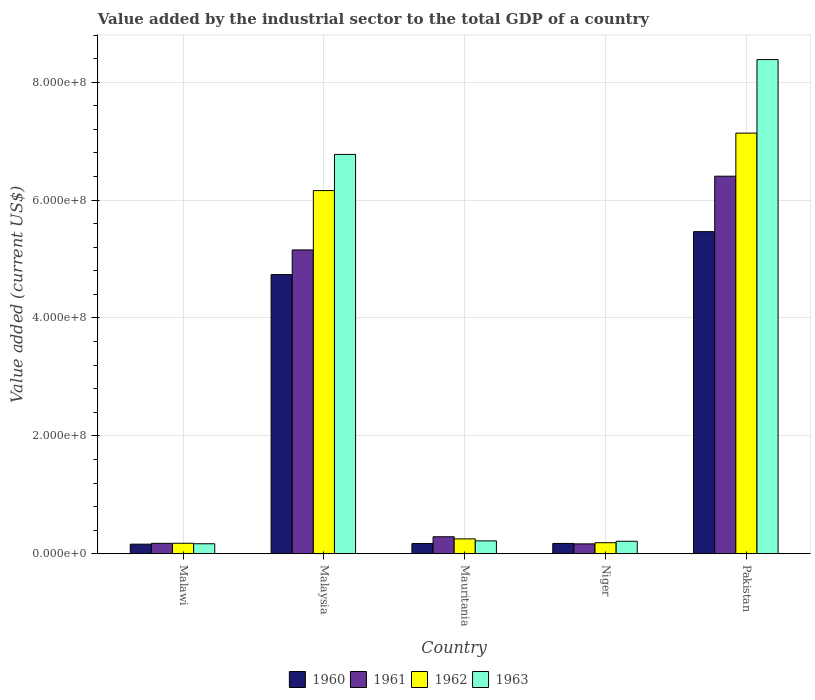How many groups of bars are there?
Your answer should be compact. 5. Are the number of bars per tick equal to the number of legend labels?
Ensure brevity in your answer.  Yes. What is the label of the 4th group of bars from the left?
Offer a terse response. Niger. What is the value added by the industrial sector to the total GDP in 1960 in Malawi?
Offer a very short reply. 1.62e+07. Across all countries, what is the maximum value added by the industrial sector to the total GDP in 1962?
Make the answer very short. 7.14e+08. Across all countries, what is the minimum value added by the industrial sector to the total GDP in 1961?
Your response must be concise. 1.67e+07. In which country was the value added by the industrial sector to the total GDP in 1963 minimum?
Give a very brief answer. Malawi. What is the total value added by the industrial sector to the total GDP in 1961 in the graph?
Offer a terse response. 1.22e+09. What is the difference between the value added by the industrial sector to the total GDP in 1963 in Malawi and that in Niger?
Offer a very short reply. -4.25e+06. What is the difference between the value added by the industrial sector to the total GDP in 1963 in Malaysia and the value added by the industrial sector to the total GDP in 1962 in Mauritania?
Your answer should be compact. 6.52e+08. What is the average value added by the industrial sector to the total GDP in 1963 per country?
Keep it short and to the point. 3.15e+08. What is the difference between the value added by the industrial sector to the total GDP of/in 1963 and value added by the industrial sector to the total GDP of/in 1960 in Malaysia?
Your answer should be very brief. 2.04e+08. In how many countries, is the value added by the industrial sector to the total GDP in 1963 greater than 640000000 US$?
Provide a succinct answer. 2. What is the ratio of the value added by the industrial sector to the total GDP in 1961 in Malaysia to that in Niger?
Give a very brief answer. 30.78. Is the value added by the industrial sector to the total GDP in 1962 in Malaysia less than that in Mauritania?
Provide a short and direct response. No. What is the difference between the highest and the second highest value added by the industrial sector to the total GDP in 1962?
Provide a short and direct response. 9.75e+07. What is the difference between the highest and the lowest value added by the industrial sector to the total GDP in 1961?
Make the answer very short. 6.24e+08. In how many countries, is the value added by the industrial sector to the total GDP in 1962 greater than the average value added by the industrial sector to the total GDP in 1962 taken over all countries?
Provide a succinct answer. 2. What does the 3rd bar from the right in Niger represents?
Your response must be concise. 1961. Is it the case that in every country, the sum of the value added by the industrial sector to the total GDP in 1963 and value added by the industrial sector to the total GDP in 1960 is greater than the value added by the industrial sector to the total GDP in 1962?
Your response must be concise. Yes. How many bars are there?
Give a very brief answer. 20. Are all the bars in the graph horizontal?
Provide a succinct answer. No. Are the values on the major ticks of Y-axis written in scientific E-notation?
Provide a short and direct response. Yes. Does the graph contain any zero values?
Ensure brevity in your answer.  No. Where does the legend appear in the graph?
Offer a very short reply. Bottom center. How many legend labels are there?
Your answer should be very brief. 4. How are the legend labels stacked?
Ensure brevity in your answer.  Horizontal. What is the title of the graph?
Keep it short and to the point. Value added by the industrial sector to the total GDP of a country. Does "1981" appear as one of the legend labels in the graph?
Your answer should be very brief. No. What is the label or title of the X-axis?
Your answer should be very brief. Country. What is the label or title of the Y-axis?
Your answer should be compact. Value added (current US$). What is the Value added (current US$) of 1960 in Malawi?
Offer a very short reply. 1.62e+07. What is the Value added (current US$) of 1961 in Malawi?
Give a very brief answer. 1.76e+07. What is the Value added (current US$) in 1962 in Malawi?
Give a very brief answer. 1.78e+07. What is the Value added (current US$) in 1963 in Malawi?
Give a very brief answer. 1.69e+07. What is the Value added (current US$) in 1960 in Malaysia?
Give a very brief answer. 4.74e+08. What is the Value added (current US$) in 1961 in Malaysia?
Make the answer very short. 5.15e+08. What is the Value added (current US$) in 1962 in Malaysia?
Offer a very short reply. 6.16e+08. What is the Value added (current US$) in 1963 in Malaysia?
Your answer should be compact. 6.77e+08. What is the Value added (current US$) in 1960 in Mauritania?
Your answer should be compact. 1.73e+07. What is the Value added (current US$) of 1961 in Mauritania?
Ensure brevity in your answer.  2.88e+07. What is the Value added (current US$) in 1962 in Mauritania?
Ensure brevity in your answer.  2.52e+07. What is the Value added (current US$) in 1963 in Mauritania?
Offer a terse response. 2.18e+07. What is the Value added (current US$) of 1960 in Niger?
Your answer should be very brief. 1.75e+07. What is the Value added (current US$) in 1961 in Niger?
Provide a short and direct response. 1.67e+07. What is the Value added (current US$) in 1962 in Niger?
Offer a terse response. 1.87e+07. What is the Value added (current US$) in 1963 in Niger?
Make the answer very short. 2.12e+07. What is the Value added (current US$) of 1960 in Pakistan?
Your answer should be compact. 5.46e+08. What is the Value added (current US$) in 1961 in Pakistan?
Provide a short and direct response. 6.40e+08. What is the Value added (current US$) of 1962 in Pakistan?
Your response must be concise. 7.14e+08. What is the Value added (current US$) of 1963 in Pakistan?
Keep it short and to the point. 8.38e+08. Across all countries, what is the maximum Value added (current US$) in 1960?
Keep it short and to the point. 5.46e+08. Across all countries, what is the maximum Value added (current US$) of 1961?
Your answer should be very brief. 6.40e+08. Across all countries, what is the maximum Value added (current US$) in 1962?
Your response must be concise. 7.14e+08. Across all countries, what is the maximum Value added (current US$) of 1963?
Your answer should be compact. 8.38e+08. Across all countries, what is the minimum Value added (current US$) in 1960?
Make the answer very short. 1.62e+07. Across all countries, what is the minimum Value added (current US$) of 1961?
Provide a short and direct response. 1.67e+07. Across all countries, what is the minimum Value added (current US$) of 1962?
Your answer should be very brief. 1.78e+07. Across all countries, what is the minimum Value added (current US$) of 1963?
Ensure brevity in your answer.  1.69e+07. What is the total Value added (current US$) of 1960 in the graph?
Your answer should be very brief. 1.07e+09. What is the total Value added (current US$) of 1961 in the graph?
Your answer should be very brief. 1.22e+09. What is the total Value added (current US$) of 1962 in the graph?
Make the answer very short. 1.39e+09. What is the total Value added (current US$) of 1963 in the graph?
Ensure brevity in your answer.  1.58e+09. What is the difference between the Value added (current US$) in 1960 in Malawi and that in Malaysia?
Make the answer very short. -4.57e+08. What is the difference between the Value added (current US$) in 1961 in Malawi and that in Malaysia?
Provide a succinct answer. -4.98e+08. What is the difference between the Value added (current US$) of 1962 in Malawi and that in Malaysia?
Give a very brief answer. -5.98e+08. What is the difference between the Value added (current US$) of 1963 in Malawi and that in Malaysia?
Your response must be concise. -6.61e+08. What is the difference between the Value added (current US$) in 1960 in Malawi and that in Mauritania?
Ensure brevity in your answer.  -1.06e+06. What is the difference between the Value added (current US$) in 1961 in Malawi and that in Mauritania?
Make the answer very short. -1.12e+07. What is the difference between the Value added (current US$) of 1962 in Malawi and that in Mauritania?
Provide a short and direct response. -7.44e+06. What is the difference between the Value added (current US$) in 1963 in Malawi and that in Mauritania?
Make the answer very short. -4.90e+06. What is the difference between the Value added (current US$) of 1960 in Malawi and that in Niger?
Ensure brevity in your answer.  -1.23e+06. What is the difference between the Value added (current US$) of 1961 in Malawi and that in Niger?
Keep it short and to the point. 8.98e+05. What is the difference between the Value added (current US$) of 1962 in Malawi and that in Niger?
Provide a short and direct response. -9.35e+05. What is the difference between the Value added (current US$) of 1963 in Malawi and that in Niger?
Keep it short and to the point. -4.25e+06. What is the difference between the Value added (current US$) of 1960 in Malawi and that in Pakistan?
Offer a terse response. -5.30e+08. What is the difference between the Value added (current US$) of 1961 in Malawi and that in Pakistan?
Ensure brevity in your answer.  -6.23e+08. What is the difference between the Value added (current US$) of 1962 in Malawi and that in Pakistan?
Provide a succinct answer. -6.96e+08. What is the difference between the Value added (current US$) of 1963 in Malawi and that in Pakistan?
Your answer should be compact. -8.21e+08. What is the difference between the Value added (current US$) of 1960 in Malaysia and that in Mauritania?
Provide a short and direct response. 4.56e+08. What is the difference between the Value added (current US$) in 1961 in Malaysia and that in Mauritania?
Provide a succinct answer. 4.87e+08. What is the difference between the Value added (current US$) of 1962 in Malaysia and that in Mauritania?
Offer a terse response. 5.91e+08. What is the difference between the Value added (current US$) of 1963 in Malaysia and that in Mauritania?
Offer a very short reply. 6.56e+08. What is the difference between the Value added (current US$) of 1960 in Malaysia and that in Niger?
Make the answer very short. 4.56e+08. What is the difference between the Value added (current US$) of 1961 in Malaysia and that in Niger?
Make the answer very short. 4.99e+08. What is the difference between the Value added (current US$) in 1962 in Malaysia and that in Niger?
Ensure brevity in your answer.  5.97e+08. What is the difference between the Value added (current US$) in 1963 in Malaysia and that in Niger?
Provide a short and direct response. 6.56e+08. What is the difference between the Value added (current US$) of 1960 in Malaysia and that in Pakistan?
Your answer should be compact. -7.29e+07. What is the difference between the Value added (current US$) in 1961 in Malaysia and that in Pakistan?
Provide a short and direct response. -1.25e+08. What is the difference between the Value added (current US$) in 1962 in Malaysia and that in Pakistan?
Give a very brief answer. -9.75e+07. What is the difference between the Value added (current US$) in 1963 in Malaysia and that in Pakistan?
Your response must be concise. -1.61e+08. What is the difference between the Value added (current US$) of 1960 in Mauritania and that in Niger?
Give a very brief answer. -1.73e+05. What is the difference between the Value added (current US$) in 1961 in Mauritania and that in Niger?
Offer a terse response. 1.21e+07. What is the difference between the Value added (current US$) of 1962 in Mauritania and that in Niger?
Offer a very short reply. 6.51e+06. What is the difference between the Value added (current US$) in 1963 in Mauritania and that in Niger?
Keep it short and to the point. 6.57e+05. What is the difference between the Value added (current US$) of 1960 in Mauritania and that in Pakistan?
Your response must be concise. -5.29e+08. What is the difference between the Value added (current US$) of 1961 in Mauritania and that in Pakistan?
Your answer should be very brief. -6.12e+08. What is the difference between the Value added (current US$) of 1962 in Mauritania and that in Pakistan?
Provide a short and direct response. -6.88e+08. What is the difference between the Value added (current US$) of 1963 in Mauritania and that in Pakistan?
Provide a short and direct response. -8.16e+08. What is the difference between the Value added (current US$) of 1960 in Niger and that in Pakistan?
Your response must be concise. -5.29e+08. What is the difference between the Value added (current US$) of 1961 in Niger and that in Pakistan?
Offer a terse response. -6.24e+08. What is the difference between the Value added (current US$) of 1962 in Niger and that in Pakistan?
Make the answer very short. -6.95e+08. What is the difference between the Value added (current US$) in 1963 in Niger and that in Pakistan?
Your answer should be compact. -8.17e+08. What is the difference between the Value added (current US$) of 1960 in Malawi and the Value added (current US$) of 1961 in Malaysia?
Make the answer very short. -4.99e+08. What is the difference between the Value added (current US$) of 1960 in Malawi and the Value added (current US$) of 1962 in Malaysia?
Make the answer very short. -6.00e+08. What is the difference between the Value added (current US$) in 1960 in Malawi and the Value added (current US$) in 1963 in Malaysia?
Offer a terse response. -6.61e+08. What is the difference between the Value added (current US$) in 1961 in Malawi and the Value added (current US$) in 1962 in Malaysia?
Make the answer very short. -5.98e+08. What is the difference between the Value added (current US$) of 1961 in Malawi and the Value added (current US$) of 1963 in Malaysia?
Provide a short and direct response. -6.60e+08. What is the difference between the Value added (current US$) in 1962 in Malawi and the Value added (current US$) in 1963 in Malaysia?
Provide a succinct answer. -6.60e+08. What is the difference between the Value added (current US$) in 1960 in Malawi and the Value added (current US$) in 1961 in Mauritania?
Provide a succinct answer. -1.26e+07. What is the difference between the Value added (current US$) in 1960 in Malawi and the Value added (current US$) in 1962 in Mauritania?
Offer a terse response. -8.98e+06. What is the difference between the Value added (current US$) in 1960 in Malawi and the Value added (current US$) in 1963 in Mauritania?
Provide a succinct answer. -5.60e+06. What is the difference between the Value added (current US$) of 1961 in Malawi and the Value added (current US$) of 1962 in Mauritania?
Your answer should be compact. -7.58e+06. What is the difference between the Value added (current US$) in 1961 in Malawi and the Value added (current US$) in 1963 in Mauritania?
Ensure brevity in your answer.  -4.20e+06. What is the difference between the Value added (current US$) in 1962 in Malawi and the Value added (current US$) in 1963 in Mauritania?
Provide a short and direct response. -4.06e+06. What is the difference between the Value added (current US$) in 1960 in Malawi and the Value added (current US$) in 1961 in Niger?
Provide a succinct answer. -5.02e+05. What is the difference between the Value added (current US$) in 1960 in Malawi and the Value added (current US$) in 1962 in Niger?
Your response must be concise. -2.48e+06. What is the difference between the Value added (current US$) of 1960 in Malawi and the Value added (current US$) of 1963 in Niger?
Make the answer very short. -4.95e+06. What is the difference between the Value added (current US$) of 1961 in Malawi and the Value added (current US$) of 1962 in Niger?
Make the answer very short. -1.08e+06. What is the difference between the Value added (current US$) of 1961 in Malawi and the Value added (current US$) of 1963 in Niger?
Give a very brief answer. -3.55e+06. What is the difference between the Value added (current US$) in 1962 in Malawi and the Value added (current US$) in 1963 in Niger?
Ensure brevity in your answer.  -3.41e+06. What is the difference between the Value added (current US$) in 1960 in Malawi and the Value added (current US$) in 1961 in Pakistan?
Provide a succinct answer. -6.24e+08. What is the difference between the Value added (current US$) of 1960 in Malawi and the Value added (current US$) of 1962 in Pakistan?
Give a very brief answer. -6.97e+08. What is the difference between the Value added (current US$) in 1960 in Malawi and the Value added (current US$) in 1963 in Pakistan?
Provide a short and direct response. -8.22e+08. What is the difference between the Value added (current US$) of 1961 in Malawi and the Value added (current US$) of 1962 in Pakistan?
Offer a very short reply. -6.96e+08. What is the difference between the Value added (current US$) in 1961 in Malawi and the Value added (current US$) in 1963 in Pakistan?
Your answer should be compact. -8.21e+08. What is the difference between the Value added (current US$) in 1962 in Malawi and the Value added (current US$) in 1963 in Pakistan?
Offer a terse response. -8.21e+08. What is the difference between the Value added (current US$) in 1960 in Malaysia and the Value added (current US$) in 1961 in Mauritania?
Offer a very short reply. 4.45e+08. What is the difference between the Value added (current US$) in 1960 in Malaysia and the Value added (current US$) in 1962 in Mauritania?
Ensure brevity in your answer.  4.48e+08. What is the difference between the Value added (current US$) in 1960 in Malaysia and the Value added (current US$) in 1963 in Mauritania?
Make the answer very short. 4.52e+08. What is the difference between the Value added (current US$) in 1961 in Malaysia and the Value added (current US$) in 1962 in Mauritania?
Offer a terse response. 4.90e+08. What is the difference between the Value added (current US$) of 1961 in Malaysia and the Value added (current US$) of 1963 in Mauritania?
Keep it short and to the point. 4.94e+08. What is the difference between the Value added (current US$) in 1962 in Malaysia and the Value added (current US$) in 1963 in Mauritania?
Make the answer very short. 5.94e+08. What is the difference between the Value added (current US$) of 1960 in Malaysia and the Value added (current US$) of 1961 in Niger?
Offer a very short reply. 4.57e+08. What is the difference between the Value added (current US$) in 1960 in Malaysia and the Value added (current US$) in 1962 in Niger?
Give a very brief answer. 4.55e+08. What is the difference between the Value added (current US$) in 1960 in Malaysia and the Value added (current US$) in 1963 in Niger?
Your answer should be very brief. 4.52e+08. What is the difference between the Value added (current US$) of 1961 in Malaysia and the Value added (current US$) of 1962 in Niger?
Give a very brief answer. 4.97e+08. What is the difference between the Value added (current US$) in 1961 in Malaysia and the Value added (current US$) in 1963 in Niger?
Ensure brevity in your answer.  4.94e+08. What is the difference between the Value added (current US$) of 1962 in Malaysia and the Value added (current US$) of 1963 in Niger?
Your answer should be very brief. 5.95e+08. What is the difference between the Value added (current US$) of 1960 in Malaysia and the Value added (current US$) of 1961 in Pakistan?
Make the answer very short. -1.67e+08. What is the difference between the Value added (current US$) in 1960 in Malaysia and the Value added (current US$) in 1962 in Pakistan?
Keep it short and to the point. -2.40e+08. What is the difference between the Value added (current US$) of 1960 in Malaysia and the Value added (current US$) of 1963 in Pakistan?
Your answer should be very brief. -3.65e+08. What is the difference between the Value added (current US$) in 1961 in Malaysia and the Value added (current US$) in 1962 in Pakistan?
Your answer should be very brief. -1.98e+08. What is the difference between the Value added (current US$) in 1961 in Malaysia and the Value added (current US$) in 1963 in Pakistan?
Your answer should be very brief. -3.23e+08. What is the difference between the Value added (current US$) in 1962 in Malaysia and the Value added (current US$) in 1963 in Pakistan?
Your response must be concise. -2.22e+08. What is the difference between the Value added (current US$) of 1960 in Mauritania and the Value added (current US$) of 1961 in Niger?
Your answer should be compact. 5.53e+05. What is the difference between the Value added (current US$) in 1960 in Mauritania and the Value added (current US$) in 1962 in Niger?
Provide a short and direct response. -1.42e+06. What is the difference between the Value added (current US$) in 1960 in Mauritania and the Value added (current US$) in 1963 in Niger?
Give a very brief answer. -3.89e+06. What is the difference between the Value added (current US$) of 1961 in Mauritania and the Value added (current US$) of 1962 in Niger?
Offer a terse response. 1.01e+07. What is the difference between the Value added (current US$) of 1961 in Mauritania and the Value added (current US$) of 1963 in Niger?
Make the answer very short. 7.64e+06. What is the difference between the Value added (current US$) of 1962 in Mauritania and the Value added (current US$) of 1963 in Niger?
Your answer should be very brief. 4.04e+06. What is the difference between the Value added (current US$) in 1960 in Mauritania and the Value added (current US$) in 1961 in Pakistan?
Offer a terse response. -6.23e+08. What is the difference between the Value added (current US$) in 1960 in Mauritania and the Value added (current US$) in 1962 in Pakistan?
Provide a short and direct response. -6.96e+08. What is the difference between the Value added (current US$) of 1960 in Mauritania and the Value added (current US$) of 1963 in Pakistan?
Your response must be concise. -8.21e+08. What is the difference between the Value added (current US$) in 1961 in Mauritania and the Value added (current US$) in 1962 in Pakistan?
Provide a short and direct response. -6.85e+08. What is the difference between the Value added (current US$) of 1961 in Mauritania and the Value added (current US$) of 1963 in Pakistan?
Ensure brevity in your answer.  -8.09e+08. What is the difference between the Value added (current US$) in 1962 in Mauritania and the Value added (current US$) in 1963 in Pakistan?
Give a very brief answer. -8.13e+08. What is the difference between the Value added (current US$) in 1960 in Niger and the Value added (current US$) in 1961 in Pakistan?
Offer a terse response. -6.23e+08. What is the difference between the Value added (current US$) of 1960 in Niger and the Value added (current US$) of 1962 in Pakistan?
Keep it short and to the point. -6.96e+08. What is the difference between the Value added (current US$) in 1960 in Niger and the Value added (current US$) in 1963 in Pakistan?
Give a very brief answer. -8.21e+08. What is the difference between the Value added (current US$) in 1961 in Niger and the Value added (current US$) in 1962 in Pakistan?
Provide a succinct answer. -6.97e+08. What is the difference between the Value added (current US$) of 1961 in Niger and the Value added (current US$) of 1963 in Pakistan?
Your response must be concise. -8.22e+08. What is the difference between the Value added (current US$) of 1962 in Niger and the Value added (current US$) of 1963 in Pakistan?
Give a very brief answer. -8.20e+08. What is the average Value added (current US$) in 1960 per country?
Your answer should be compact. 2.14e+08. What is the average Value added (current US$) in 1961 per country?
Make the answer very short. 2.44e+08. What is the average Value added (current US$) in 1962 per country?
Your answer should be very brief. 2.78e+08. What is the average Value added (current US$) in 1963 per country?
Make the answer very short. 3.15e+08. What is the difference between the Value added (current US$) in 1960 and Value added (current US$) in 1961 in Malawi?
Give a very brief answer. -1.40e+06. What is the difference between the Value added (current US$) of 1960 and Value added (current US$) of 1962 in Malawi?
Ensure brevity in your answer.  -1.54e+06. What is the difference between the Value added (current US$) of 1960 and Value added (current US$) of 1963 in Malawi?
Your response must be concise. -7.00e+05. What is the difference between the Value added (current US$) of 1961 and Value added (current US$) of 1962 in Malawi?
Offer a very short reply. -1.40e+05. What is the difference between the Value added (current US$) in 1961 and Value added (current US$) in 1963 in Malawi?
Keep it short and to the point. 7.00e+05. What is the difference between the Value added (current US$) in 1962 and Value added (current US$) in 1963 in Malawi?
Offer a very short reply. 8.40e+05. What is the difference between the Value added (current US$) in 1960 and Value added (current US$) in 1961 in Malaysia?
Provide a succinct answer. -4.19e+07. What is the difference between the Value added (current US$) of 1960 and Value added (current US$) of 1962 in Malaysia?
Your answer should be very brief. -1.43e+08. What is the difference between the Value added (current US$) in 1960 and Value added (current US$) in 1963 in Malaysia?
Your answer should be compact. -2.04e+08. What is the difference between the Value added (current US$) of 1961 and Value added (current US$) of 1962 in Malaysia?
Your answer should be compact. -1.01e+08. What is the difference between the Value added (current US$) in 1961 and Value added (current US$) in 1963 in Malaysia?
Your response must be concise. -1.62e+08. What is the difference between the Value added (current US$) of 1962 and Value added (current US$) of 1963 in Malaysia?
Provide a short and direct response. -6.14e+07. What is the difference between the Value added (current US$) in 1960 and Value added (current US$) in 1961 in Mauritania?
Give a very brief answer. -1.15e+07. What is the difference between the Value added (current US$) of 1960 and Value added (current US$) of 1962 in Mauritania?
Your answer should be compact. -7.93e+06. What is the difference between the Value added (current US$) in 1960 and Value added (current US$) in 1963 in Mauritania?
Your answer should be compact. -4.55e+06. What is the difference between the Value added (current US$) in 1961 and Value added (current US$) in 1962 in Mauritania?
Keep it short and to the point. 3.60e+06. What is the difference between the Value added (current US$) in 1961 and Value added (current US$) in 1963 in Mauritania?
Offer a very short reply. 6.98e+06. What is the difference between the Value added (current US$) of 1962 and Value added (current US$) of 1963 in Mauritania?
Give a very brief answer. 3.38e+06. What is the difference between the Value added (current US$) in 1960 and Value added (current US$) in 1961 in Niger?
Offer a very short reply. 7.26e+05. What is the difference between the Value added (current US$) in 1960 and Value added (current US$) in 1962 in Niger?
Ensure brevity in your answer.  -1.25e+06. What is the difference between the Value added (current US$) of 1960 and Value added (current US$) of 1963 in Niger?
Give a very brief answer. -3.72e+06. What is the difference between the Value added (current US$) in 1961 and Value added (current US$) in 1962 in Niger?
Your answer should be compact. -1.97e+06. What is the difference between the Value added (current US$) of 1961 and Value added (current US$) of 1963 in Niger?
Your answer should be compact. -4.44e+06. What is the difference between the Value added (current US$) of 1962 and Value added (current US$) of 1963 in Niger?
Your response must be concise. -2.47e+06. What is the difference between the Value added (current US$) in 1960 and Value added (current US$) in 1961 in Pakistan?
Offer a very short reply. -9.41e+07. What is the difference between the Value added (current US$) of 1960 and Value added (current US$) of 1962 in Pakistan?
Your answer should be compact. -1.67e+08. What is the difference between the Value added (current US$) in 1960 and Value added (current US$) in 1963 in Pakistan?
Provide a succinct answer. -2.92e+08. What is the difference between the Value added (current US$) in 1961 and Value added (current US$) in 1962 in Pakistan?
Offer a terse response. -7.31e+07. What is the difference between the Value added (current US$) of 1961 and Value added (current US$) of 1963 in Pakistan?
Offer a very short reply. -1.98e+08. What is the difference between the Value added (current US$) of 1962 and Value added (current US$) of 1963 in Pakistan?
Provide a short and direct response. -1.25e+08. What is the ratio of the Value added (current US$) of 1960 in Malawi to that in Malaysia?
Give a very brief answer. 0.03. What is the ratio of the Value added (current US$) of 1961 in Malawi to that in Malaysia?
Offer a terse response. 0.03. What is the ratio of the Value added (current US$) of 1962 in Malawi to that in Malaysia?
Offer a terse response. 0.03. What is the ratio of the Value added (current US$) of 1963 in Malawi to that in Malaysia?
Provide a short and direct response. 0.03. What is the ratio of the Value added (current US$) in 1960 in Malawi to that in Mauritania?
Provide a short and direct response. 0.94. What is the ratio of the Value added (current US$) in 1961 in Malawi to that in Mauritania?
Your response must be concise. 0.61. What is the ratio of the Value added (current US$) of 1962 in Malawi to that in Mauritania?
Your answer should be compact. 0.7. What is the ratio of the Value added (current US$) of 1963 in Malawi to that in Mauritania?
Offer a very short reply. 0.78. What is the ratio of the Value added (current US$) in 1960 in Malawi to that in Niger?
Make the answer very short. 0.93. What is the ratio of the Value added (current US$) in 1961 in Malawi to that in Niger?
Offer a very short reply. 1.05. What is the ratio of the Value added (current US$) of 1962 in Malawi to that in Niger?
Make the answer very short. 0.95. What is the ratio of the Value added (current US$) of 1963 in Malawi to that in Niger?
Your response must be concise. 0.8. What is the ratio of the Value added (current US$) in 1960 in Malawi to that in Pakistan?
Make the answer very short. 0.03. What is the ratio of the Value added (current US$) of 1961 in Malawi to that in Pakistan?
Provide a succinct answer. 0.03. What is the ratio of the Value added (current US$) in 1962 in Malawi to that in Pakistan?
Offer a terse response. 0.02. What is the ratio of the Value added (current US$) of 1963 in Malawi to that in Pakistan?
Your answer should be compact. 0.02. What is the ratio of the Value added (current US$) in 1960 in Malaysia to that in Mauritania?
Offer a terse response. 27.38. What is the ratio of the Value added (current US$) in 1961 in Malaysia to that in Mauritania?
Provide a short and direct response. 17.88. What is the ratio of the Value added (current US$) of 1962 in Malaysia to that in Mauritania?
Your answer should be compact. 24.43. What is the ratio of the Value added (current US$) of 1963 in Malaysia to that in Mauritania?
Your answer should be compact. 31.01. What is the ratio of the Value added (current US$) of 1960 in Malaysia to that in Niger?
Your answer should be very brief. 27.11. What is the ratio of the Value added (current US$) in 1961 in Malaysia to that in Niger?
Offer a very short reply. 30.78. What is the ratio of the Value added (current US$) in 1962 in Malaysia to that in Niger?
Make the answer very short. 32.92. What is the ratio of the Value added (current US$) in 1963 in Malaysia to that in Niger?
Your answer should be very brief. 31.98. What is the ratio of the Value added (current US$) of 1960 in Malaysia to that in Pakistan?
Provide a succinct answer. 0.87. What is the ratio of the Value added (current US$) in 1961 in Malaysia to that in Pakistan?
Provide a succinct answer. 0.8. What is the ratio of the Value added (current US$) of 1962 in Malaysia to that in Pakistan?
Offer a terse response. 0.86. What is the ratio of the Value added (current US$) of 1963 in Malaysia to that in Pakistan?
Your answer should be very brief. 0.81. What is the ratio of the Value added (current US$) in 1961 in Mauritania to that in Niger?
Keep it short and to the point. 1.72. What is the ratio of the Value added (current US$) in 1962 in Mauritania to that in Niger?
Provide a succinct answer. 1.35. What is the ratio of the Value added (current US$) in 1963 in Mauritania to that in Niger?
Offer a very short reply. 1.03. What is the ratio of the Value added (current US$) in 1960 in Mauritania to that in Pakistan?
Offer a very short reply. 0.03. What is the ratio of the Value added (current US$) in 1961 in Mauritania to that in Pakistan?
Make the answer very short. 0.04. What is the ratio of the Value added (current US$) in 1962 in Mauritania to that in Pakistan?
Your answer should be very brief. 0.04. What is the ratio of the Value added (current US$) in 1963 in Mauritania to that in Pakistan?
Your answer should be very brief. 0.03. What is the ratio of the Value added (current US$) of 1960 in Niger to that in Pakistan?
Provide a short and direct response. 0.03. What is the ratio of the Value added (current US$) of 1961 in Niger to that in Pakistan?
Offer a terse response. 0.03. What is the ratio of the Value added (current US$) of 1962 in Niger to that in Pakistan?
Your response must be concise. 0.03. What is the ratio of the Value added (current US$) of 1963 in Niger to that in Pakistan?
Keep it short and to the point. 0.03. What is the difference between the highest and the second highest Value added (current US$) of 1960?
Provide a short and direct response. 7.29e+07. What is the difference between the highest and the second highest Value added (current US$) of 1961?
Your answer should be very brief. 1.25e+08. What is the difference between the highest and the second highest Value added (current US$) in 1962?
Give a very brief answer. 9.75e+07. What is the difference between the highest and the second highest Value added (current US$) in 1963?
Provide a short and direct response. 1.61e+08. What is the difference between the highest and the lowest Value added (current US$) in 1960?
Your answer should be very brief. 5.30e+08. What is the difference between the highest and the lowest Value added (current US$) of 1961?
Provide a short and direct response. 6.24e+08. What is the difference between the highest and the lowest Value added (current US$) in 1962?
Provide a succinct answer. 6.96e+08. What is the difference between the highest and the lowest Value added (current US$) of 1963?
Keep it short and to the point. 8.21e+08. 